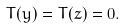<formula> <loc_0><loc_0><loc_500><loc_500>T ( y ) = T ( z ) = 0 .</formula> 